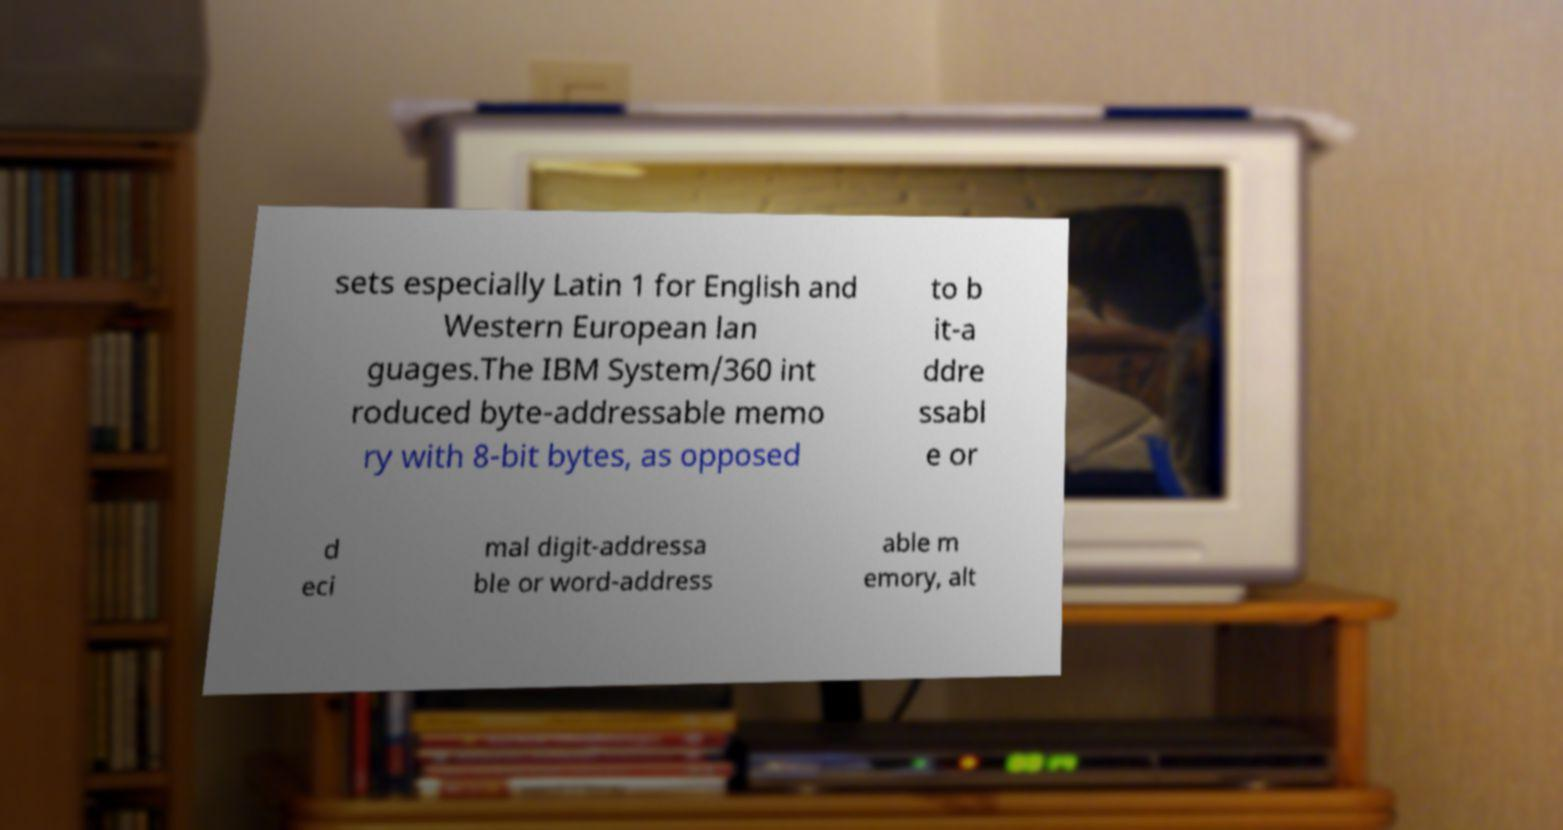For documentation purposes, I need the text within this image transcribed. Could you provide that? sets especially Latin 1 for English and Western European lan guages.The IBM System/360 int roduced byte-addressable memo ry with 8-bit bytes, as opposed to b it-a ddre ssabl e or d eci mal digit-addressa ble or word-address able m emory, alt 